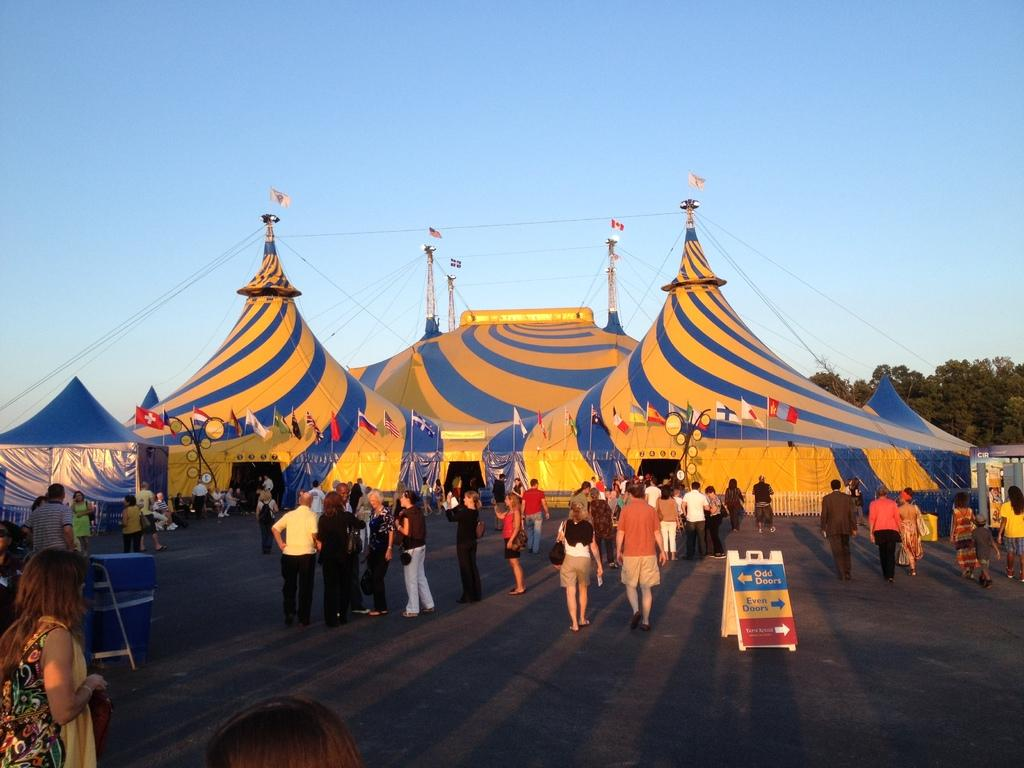How many people are in the image? There is a group of people in the image, but the exact number is not specified. What are some of the people in the image doing? Some people are standing, while others are walking. What can be seen on the board in the image? The facts do not specify what is on the board. What type of flags are present in the image? The facts do not specify the type of flags. What are the tents used for in the image? The purpose of the tents is not specified in the facts. What type of trees are in the image? The facts do not specify the type of trees. What are some of the various objects in the image? The facts do not specify that there are various objects in the image, but they do not list them. What is the condition of the sky in the image? The sky is visible in the background of the image, but the condition (e.g., clear, cloudy) is not specified. What type of grain is being harvested in the image? There is no mention of grain or harvesting in the image. 